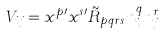Convert formula to latex. <formula><loc_0><loc_0><loc_500><loc_500>V _ { i j } = x ^ { p \prime } x ^ { s \prime } { \tilde { R } } _ { p q r s } { { n } ^ { q } _ { i } } { { n } ^ { r } _ { j } }</formula> 